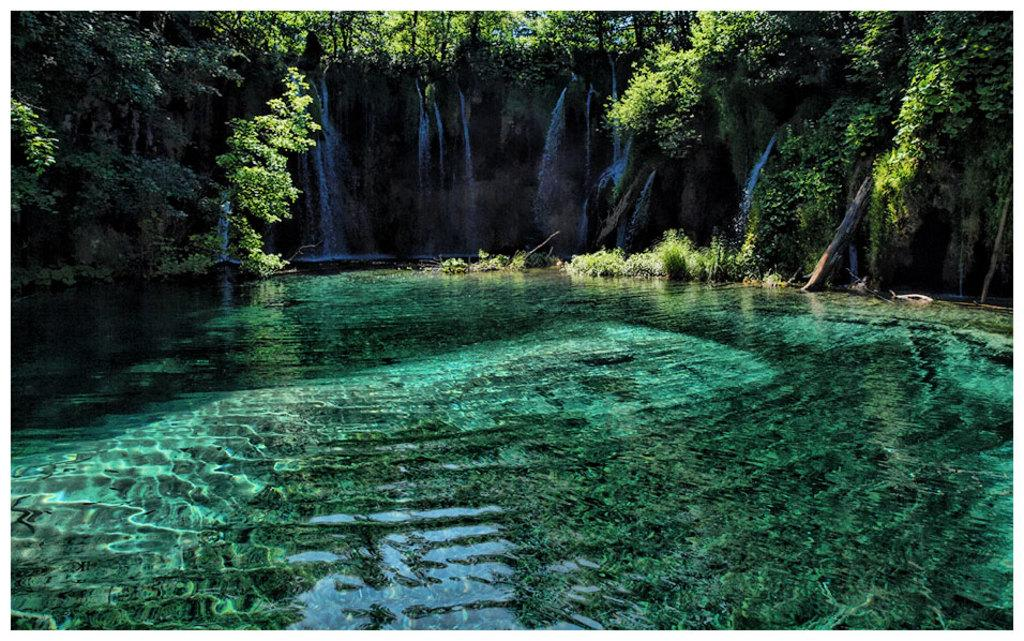What is the primary element visible in the image? There is water in the image. What can be seen in the distance in the image? There are trees in the background of the image. What type of grain is being harvested in the image? There is no grain or harvesting activity present in the image; it features water and trees. 